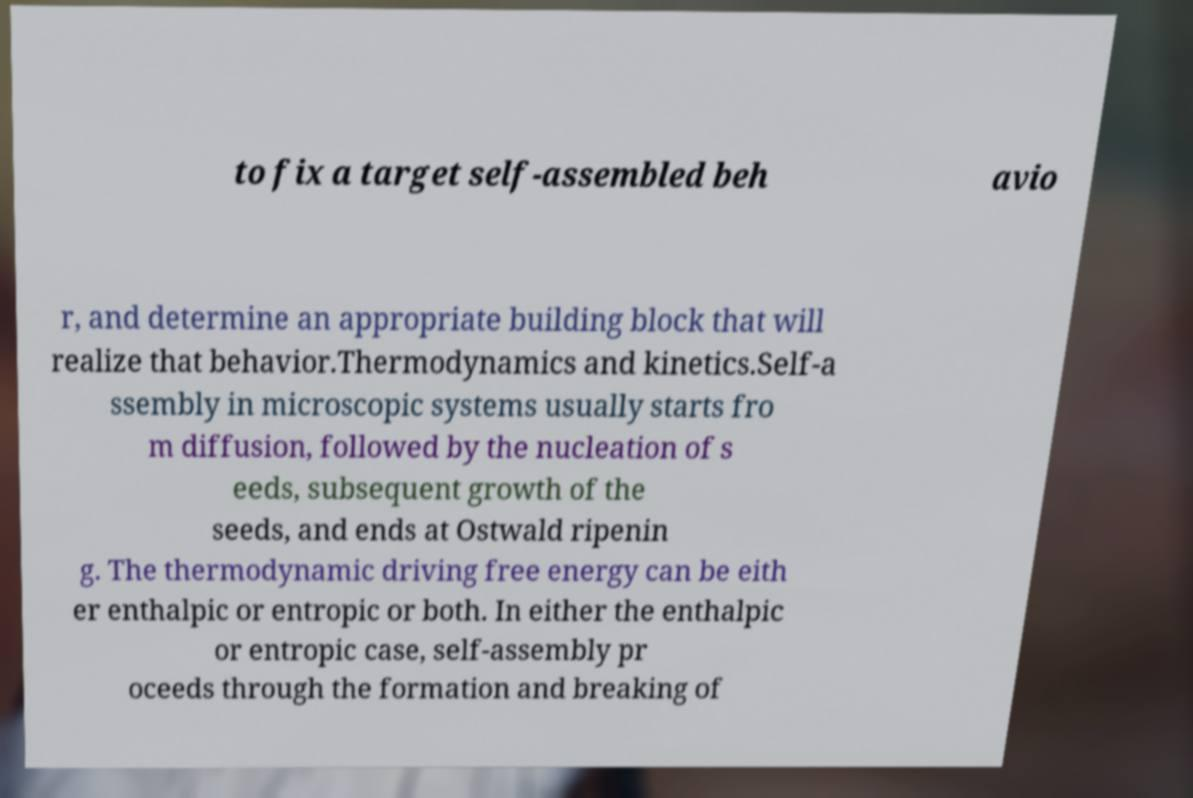There's text embedded in this image that I need extracted. Can you transcribe it verbatim? to fix a target self-assembled beh avio r, and determine an appropriate building block that will realize that behavior.Thermodynamics and kinetics.Self-a ssembly in microscopic systems usually starts fro m diffusion, followed by the nucleation of s eeds, subsequent growth of the seeds, and ends at Ostwald ripenin g. The thermodynamic driving free energy can be eith er enthalpic or entropic or both. In either the enthalpic or entropic case, self-assembly pr oceeds through the formation and breaking of 